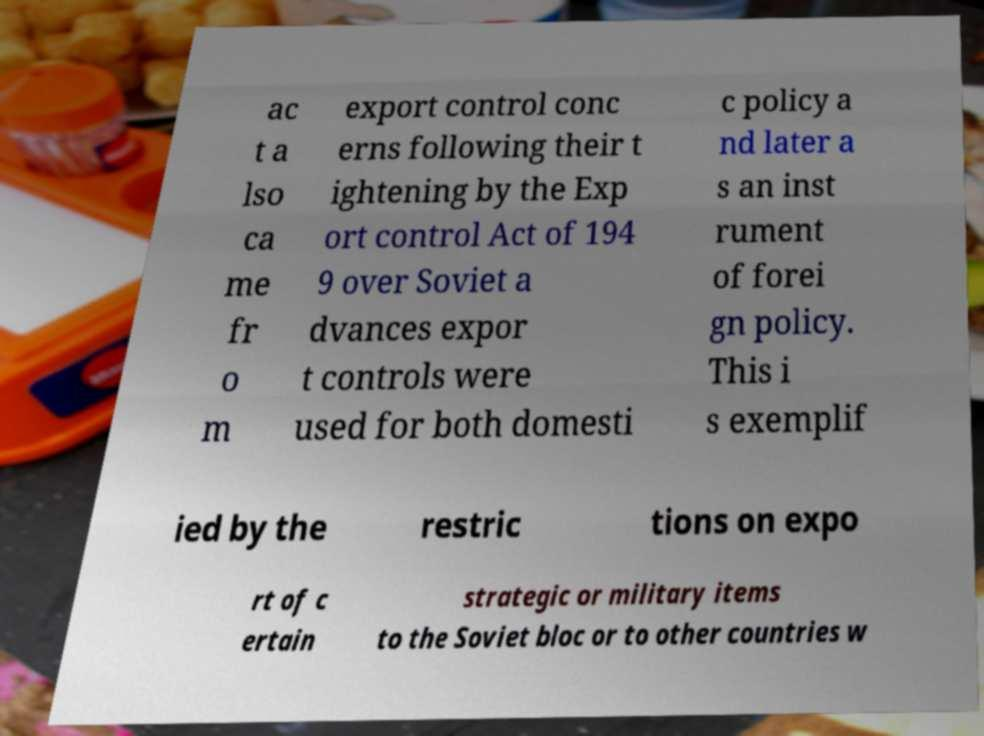What messages or text are displayed in this image? I need them in a readable, typed format. ac t a lso ca me fr o m export control conc erns following their t ightening by the Exp ort control Act of 194 9 over Soviet a dvances expor t controls were used for both domesti c policy a nd later a s an inst rument of forei gn policy. This i s exemplif ied by the restric tions on expo rt of c ertain strategic or military items to the Soviet bloc or to other countries w 